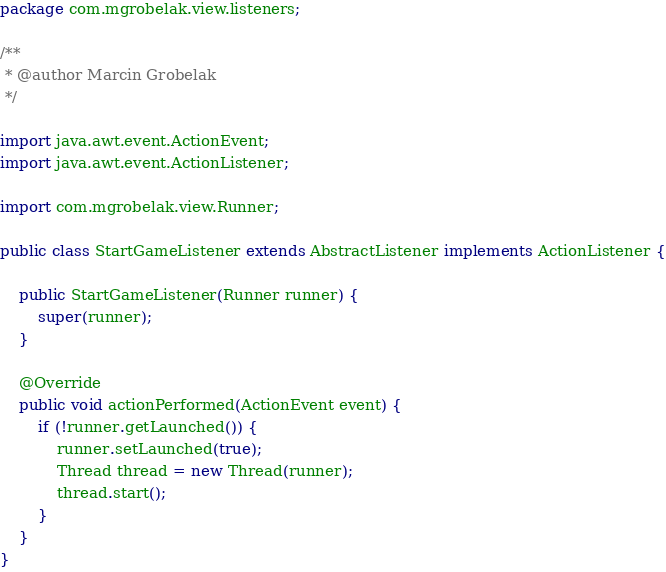Convert code to text. <code><loc_0><loc_0><loc_500><loc_500><_Java_>package com.mgrobelak.view.listeners;

/**
 * @author Marcin Grobelak
 */

import java.awt.event.ActionEvent;
import java.awt.event.ActionListener;

import com.mgrobelak.view.Runner;

public class StartGameListener extends AbstractListener implements ActionListener {

	public StartGameListener(Runner runner) {
		super(runner);
	}

	@Override
	public void actionPerformed(ActionEvent event) {
		if (!runner.getLaunched()) {
			runner.setLaunched(true);
			Thread thread = new Thread(runner);
			thread.start();
		}
	}
}
</code> 